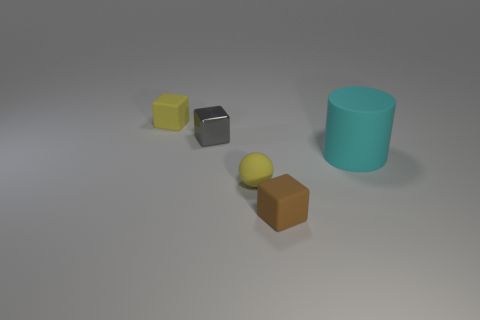Add 3 balls. How many objects exist? 8 Subtract all brown matte blocks. How many blocks are left? 2 Subtract all brown blocks. How many blocks are left? 2 Subtract 2 blocks. How many blocks are left? 1 Add 5 brown rubber blocks. How many brown rubber blocks exist? 6 Subtract 0 green balls. How many objects are left? 5 Subtract all spheres. How many objects are left? 4 Subtract all purple cubes. Subtract all blue balls. How many cubes are left? 3 Subtract all gray cylinders. How many green spheres are left? 0 Subtract all gray shiny cubes. Subtract all metal objects. How many objects are left? 3 